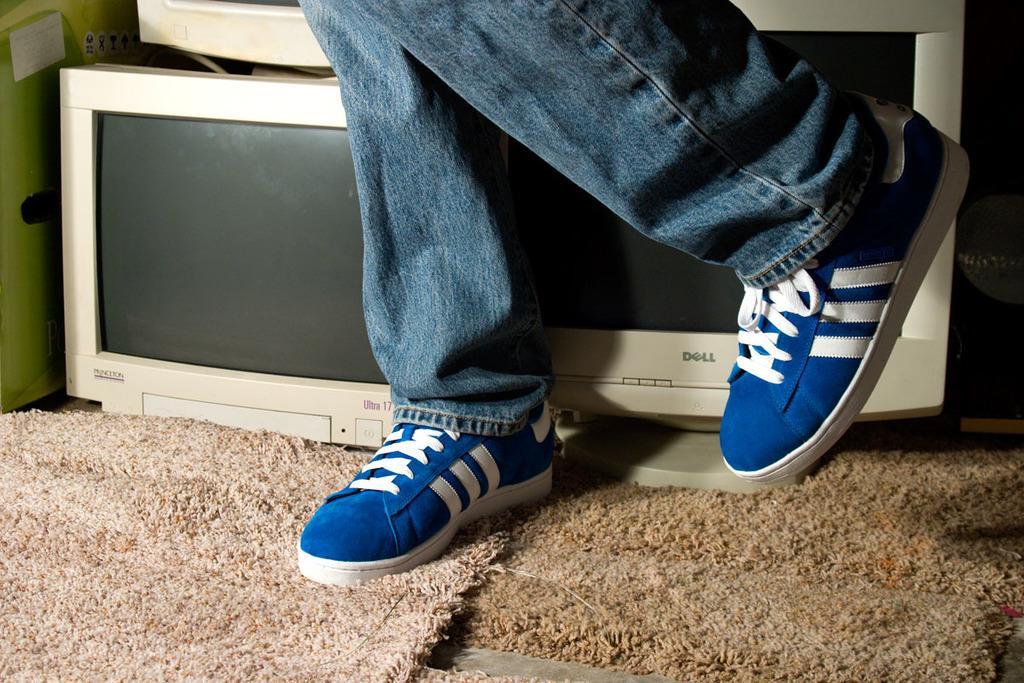Describe this image in one or two sentences. In this picture I can see a person legs with shoes and also I can see some systems are placed on the cloth. 